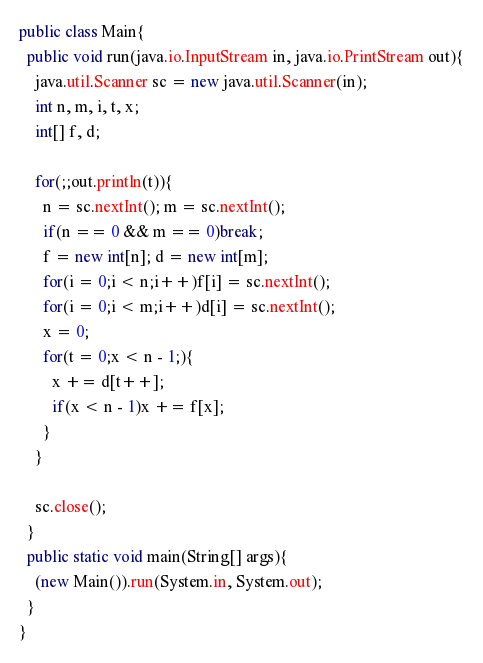<code> <loc_0><loc_0><loc_500><loc_500><_Java_>public class Main{
  public void run(java.io.InputStream in, java.io.PrintStream out){
    java.util.Scanner sc = new java.util.Scanner(in);
    int n, m, i, t, x;
    int[] f, d;

    for(;;out.println(t)){
      n = sc.nextInt(); m = sc.nextInt();
      if(n == 0 && m == 0)break;
      f = new int[n]; d = new int[m];
      for(i = 0;i < n;i++)f[i] = sc.nextInt();
      for(i = 0;i < m;i++)d[i] = sc.nextInt();
      x = 0;
      for(t = 0;x < n - 1;){
        x += d[t++];
        if(x < n - 1)x += f[x];
      }
    }

    sc.close();
  }
  public static void main(String[] args){
    (new Main()).run(System.in, System.out);
  }
}</code> 